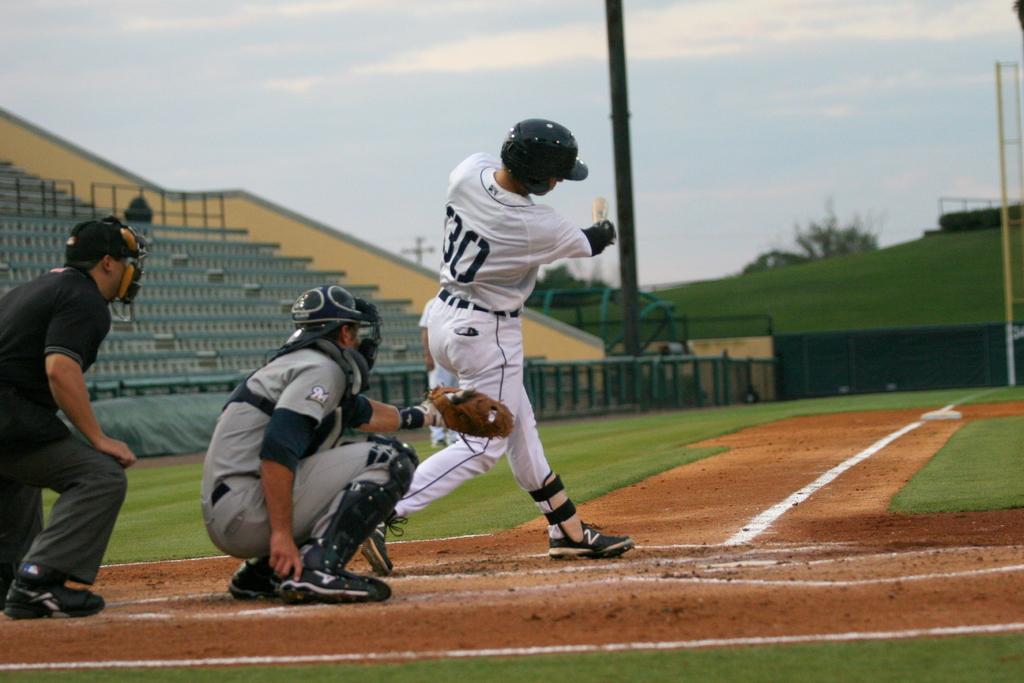What number is the batter wearing?
Make the answer very short. 30. 